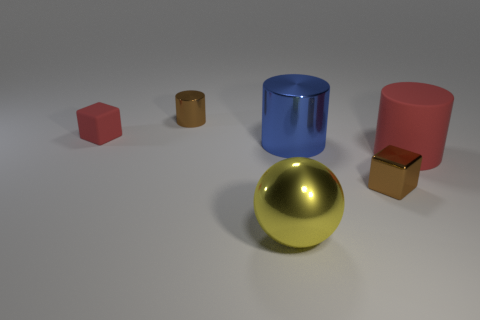Add 3 red matte blocks. How many objects exist? 9 Subtract all blocks. How many objects are left? 4 Add 4 small red blocks. How many small red blocks exist? 5 Subtract 0 cyan cylinders. How many objects are left? 6 Subtract all big rubber spheres. Subtract all matte cylinders. How many objects are left? 5 Add 3 tiny brown things. How many tiny brown things are left? 5 